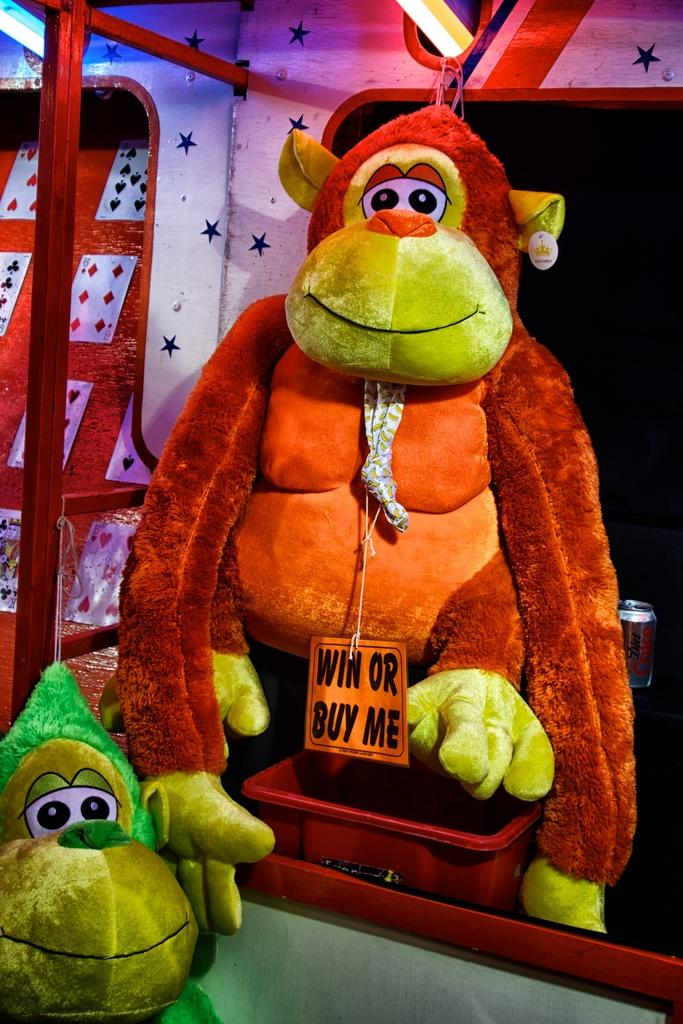What types of objects can be seen in the image? There are toys and cards in the image. Are there any light sources visible in the image? Yes, there are lights in the image. What is the color of the stand in the image? The stand in the image is red. Can you describe any objects that have a combination of red and white colors in the image? Yes, there are objects in the image that are red and white in color. How many mice are hiding behind the red stand in the image? There are no mice present in the image. What type of iron is being used to hold the cards in the image? There is no iron visible in the image, and the cards are not being held by any iron object. 